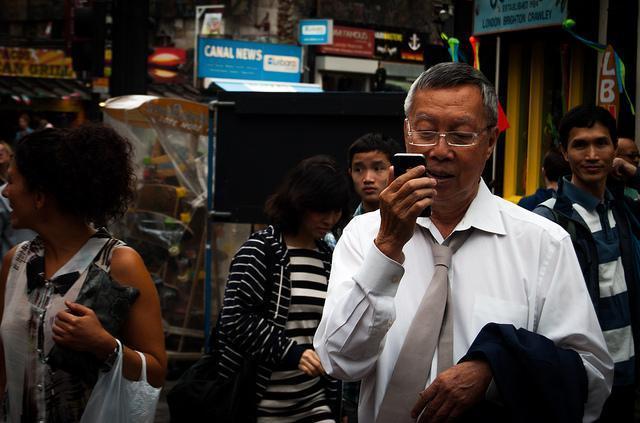How many handbags are there?
Give a very brief answer. 3. How many people are there?
Give a very brief answer. 6. How many motorcycles are parked?
Give a very brief answer. 0. 